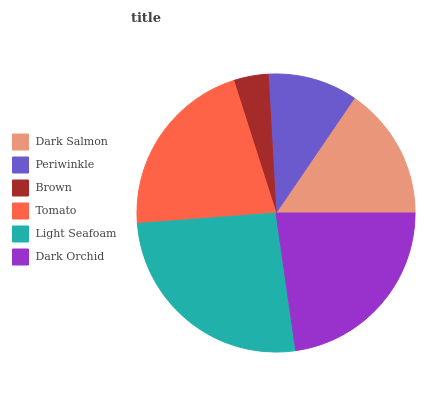Is Brown the minimum?
Answer yes or no. Yes. Is Light Seafoam the maximum?
Answer yes or no. Yes. Is Periwinkle the minimum?
Answer yes or no. No. Is Periwinkle the maximum?
Answer yes or no. No. Is Dark Salmon greater than Periwinkle?
Answer yes or no. Yes. Is Periwinkle less than Dark Salmon?
Answer yes or no. Yes. Is Periwinkle greater than Dark Salmon?
Answer yes or no. No. Is Dark Salmon less than Periwinkle?
Answer yes or no. No. Is Tomato the high median?
Answer yes or no. Yes. Is Dark Salmon the low median?
Answer yes or no. Yes. Is Periwinkle the high median?
Answer yes or no. No. Is Light Seafoam the low median?
Answer yes or no. No. 